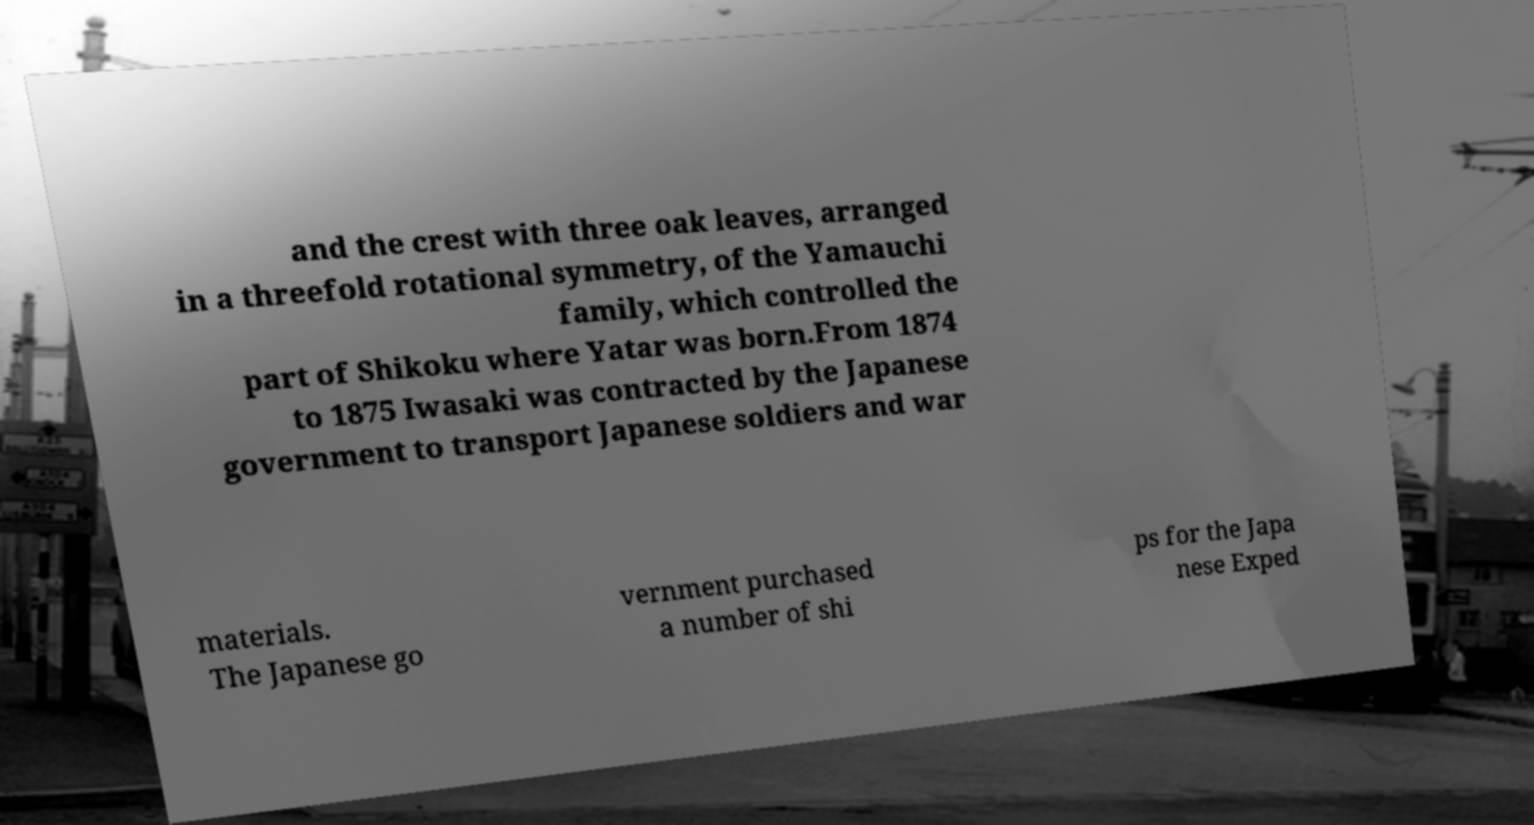I need the written content from this picture converted into text. Can you do that? and the crest with three oak leaves, arranged in a threefold rotational symmetry, of the Yamauchi family, which controlled the part of Shikoku where Yatar was born.From 1874 to 1875 Iwasaki was contracted by the Japanese government to transport Japanese soldiers and war materials. The Japanese go vernment purchased a number of shi ps for the Japa nese Exped 